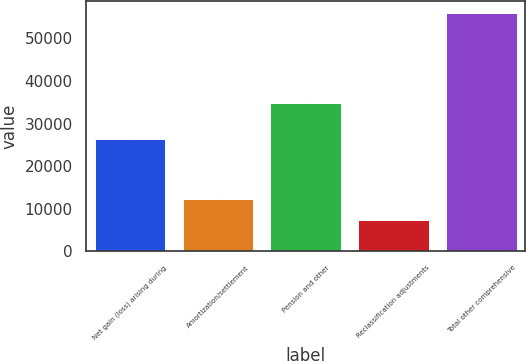Convert chart to OTSL. <chart><loc_0><loc_0><loc_500><loc_500><bar_chart><fcel>Net gain (loss) arising during<fcel>Amortization/settlement<fcel>Pension and other<fcel>Reclassification adjustments<fcel>Total other comprehensive<nl><fcel>26274<fcel>12274.5<fcel>34873<fcel>7430<fcel>55875<nl></chart> 